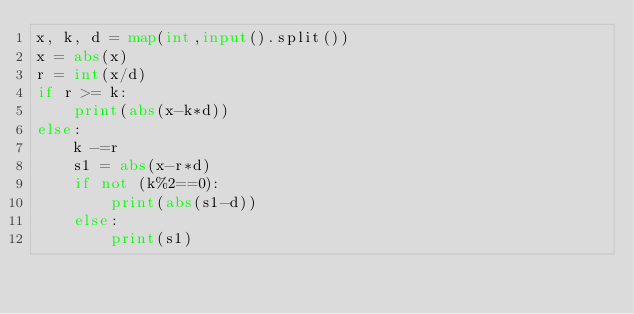Convert code to text. <code><loc_0><loc_0><loc_500><loc_500><_Python_>x, k, d = map(int,input().split())
x = abs(x)
r = int(x/d)
if r >= k:
    print(abs(x-k*d))
else:
    k -=r
    s1 = abs(x-r*d)
    if not (k%2==0):
        print(abs(s1-d))
    else:
        print(s1)</code> 